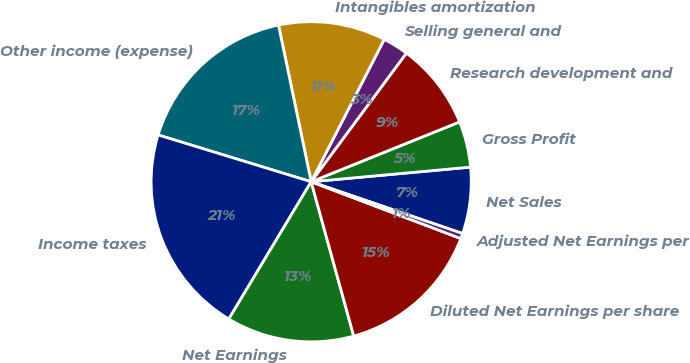Convert chart to OTSL. <chart><loc_0><loc_0><loc_500><loc_500><pie_chart><fcel>Net Sales<fcel>Gross Profit<fcel>Research development and<fcel>Selling general and<fcel>Intangibles amortization<fcel>Other income (expense)<fcel>Income taxes<fcel>Net Earnings<fcel>Diluted Net Earnings per share<fcel>Adjusted Net Earnings per<nl><fcel>6.7%<fcel>4.64%<fcel>8.76%<fcel>2.59%<fcel>10.82%<fcel>17.0%<fcel>21.12%<fcel>12.88%<fcel>14.94%<fcel>0.53%<nl></chart> 